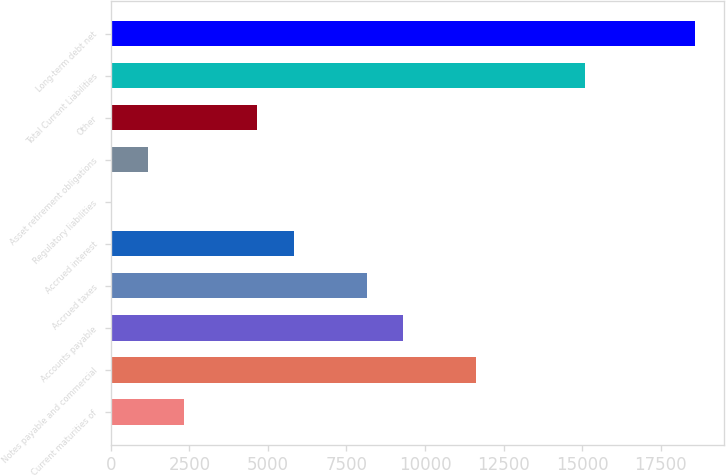Convert chart to OTSL. <chart><loc_0><loc_0><loc_500><loc_500><bar_chart><fcel>Current maturities of<fcel>Notes payable and commercial<fcel>Accounts payable<fcel>Accrued taxes<fcel>Accrued interest<fcel>Regulatory liabilities<fcel>Asset retirement obligations<fcel>Other<fcel>Total Current Liabilities<fcel>Long-term debt net<nl><fcel>2334.16<fcel>11624.4<fcel>9301.84<fcel>8140.56<fcel>5818<fcel>11.6<fcel>1172.88<fcel>4656.72<fcel>15108.2<fcel>18592.1<nl></chart> 